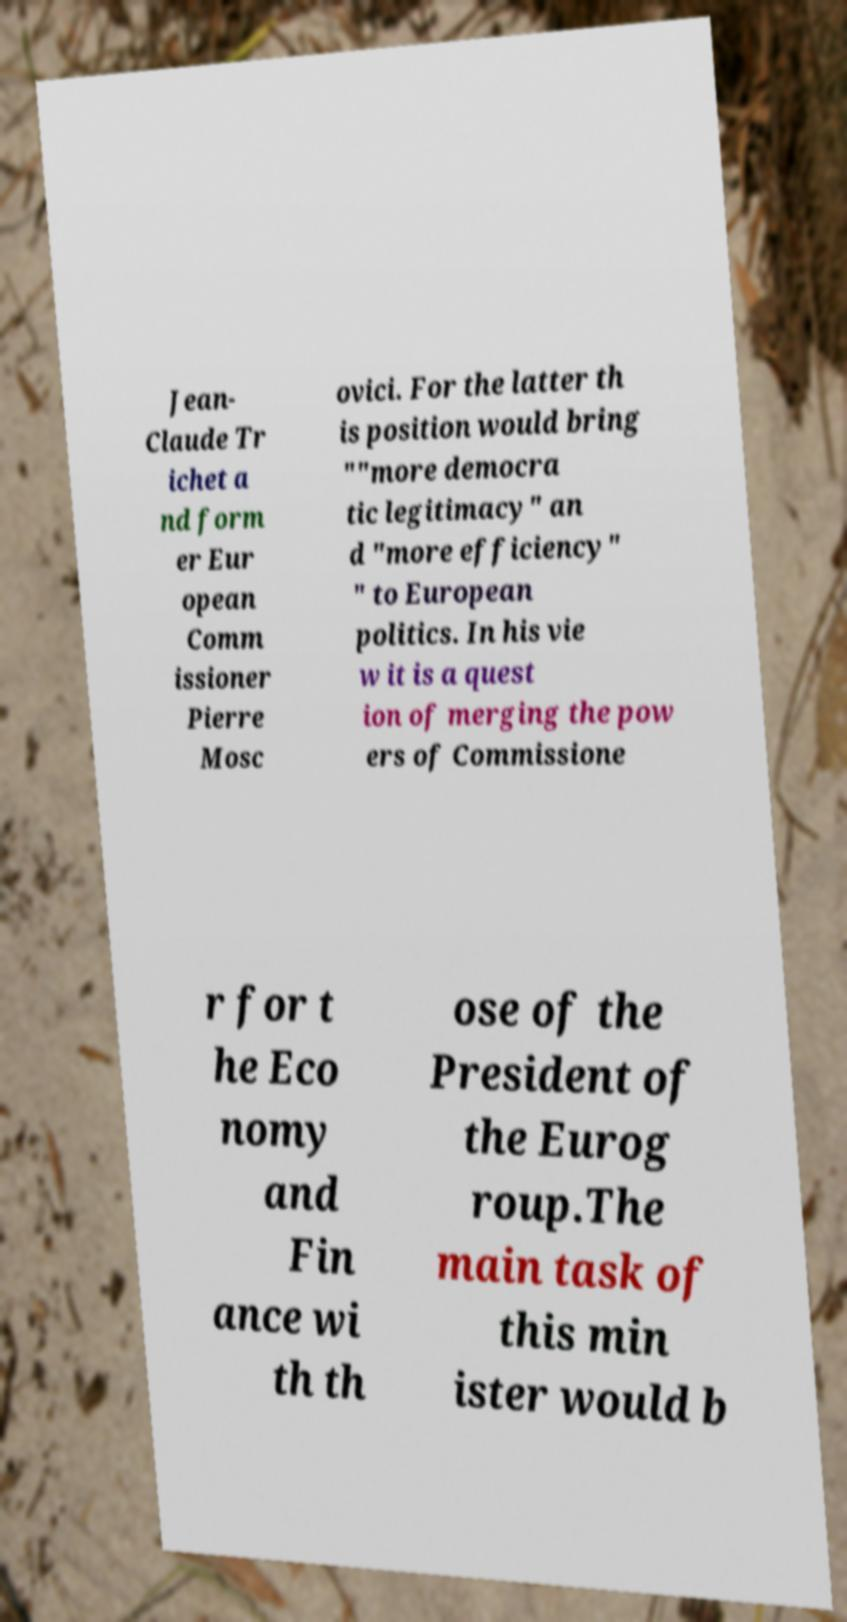There's text embedded in this image that I need extracted. Can you transcribe it verbatim? Jean- Claude Tr ichet a nd form er Eur opean Comm issioner Pierre Mosc ovici. For the latter th is position would bring ""more democra tic legitimacy" an d "more efficiency" " to European politics. In his vie w it is a quest ion of merging the pow ers of Commissione r for t he Eco nomy and Fin ance wi th th ose of the President of the Eurog roup.The main task of this min ister would b 